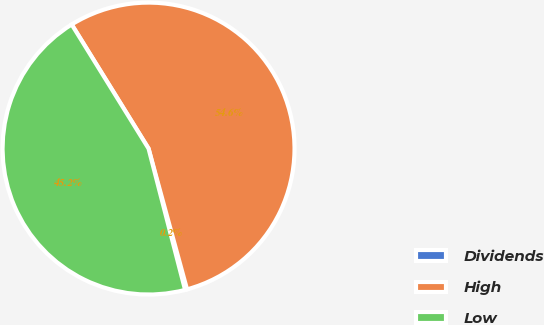<chart> <loc_0><loc_0><loc_500><loc_500><pie_chart><fcel>Dividends<fcel>High<fcel>Low<nl><fcel>0.22%<fcel>54.58%<fcel>45.2%<nl></chart> 